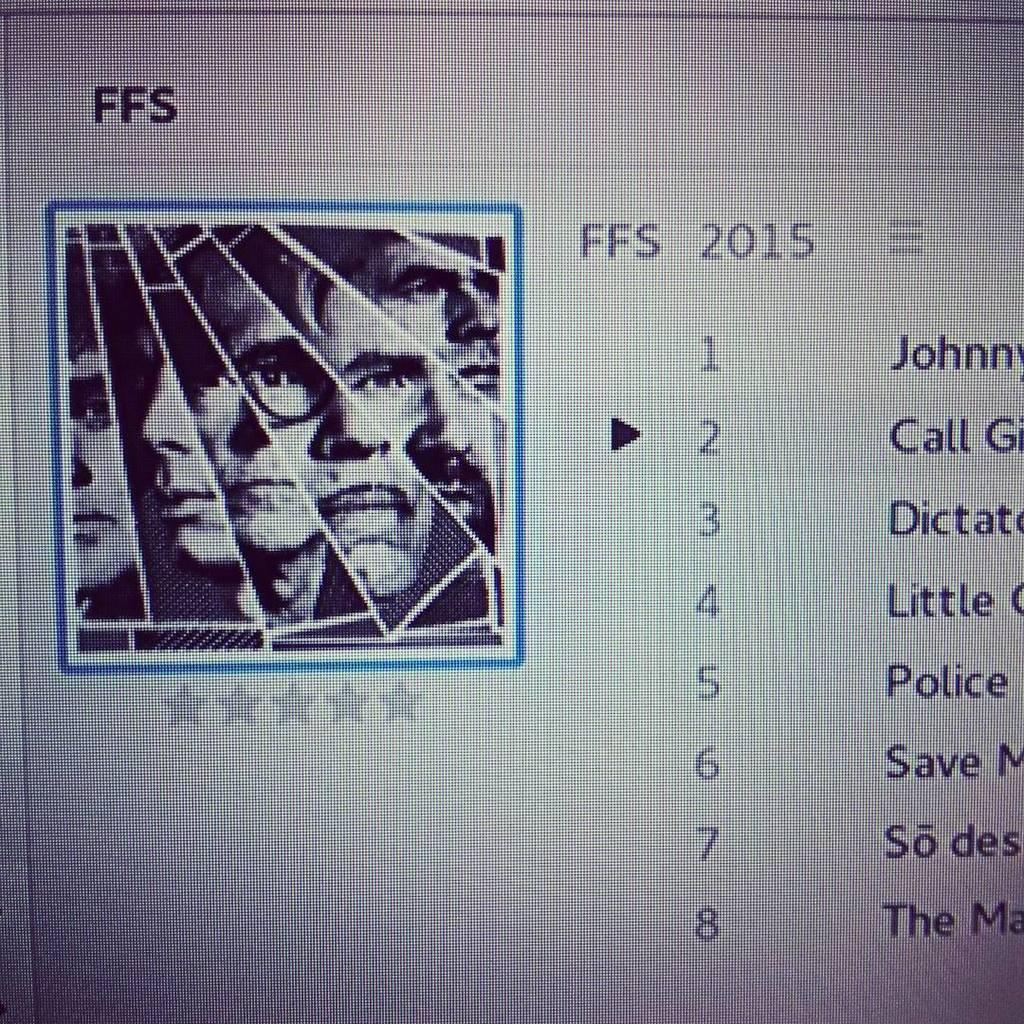What is the main subject of the image? The main subject of the image is a quiz with 8 options. What is the color scheme of the image? The image is in black and white color. How is the image composed? The image is a collage. Are there any additional elements at the bottom of the collage? Yes, there are 5 stars at the bottom of the collage. What type of bag is being used by the band in the image? There is no bag or band present in the image; it is a quiz with 8 options in a black and white collage format. 